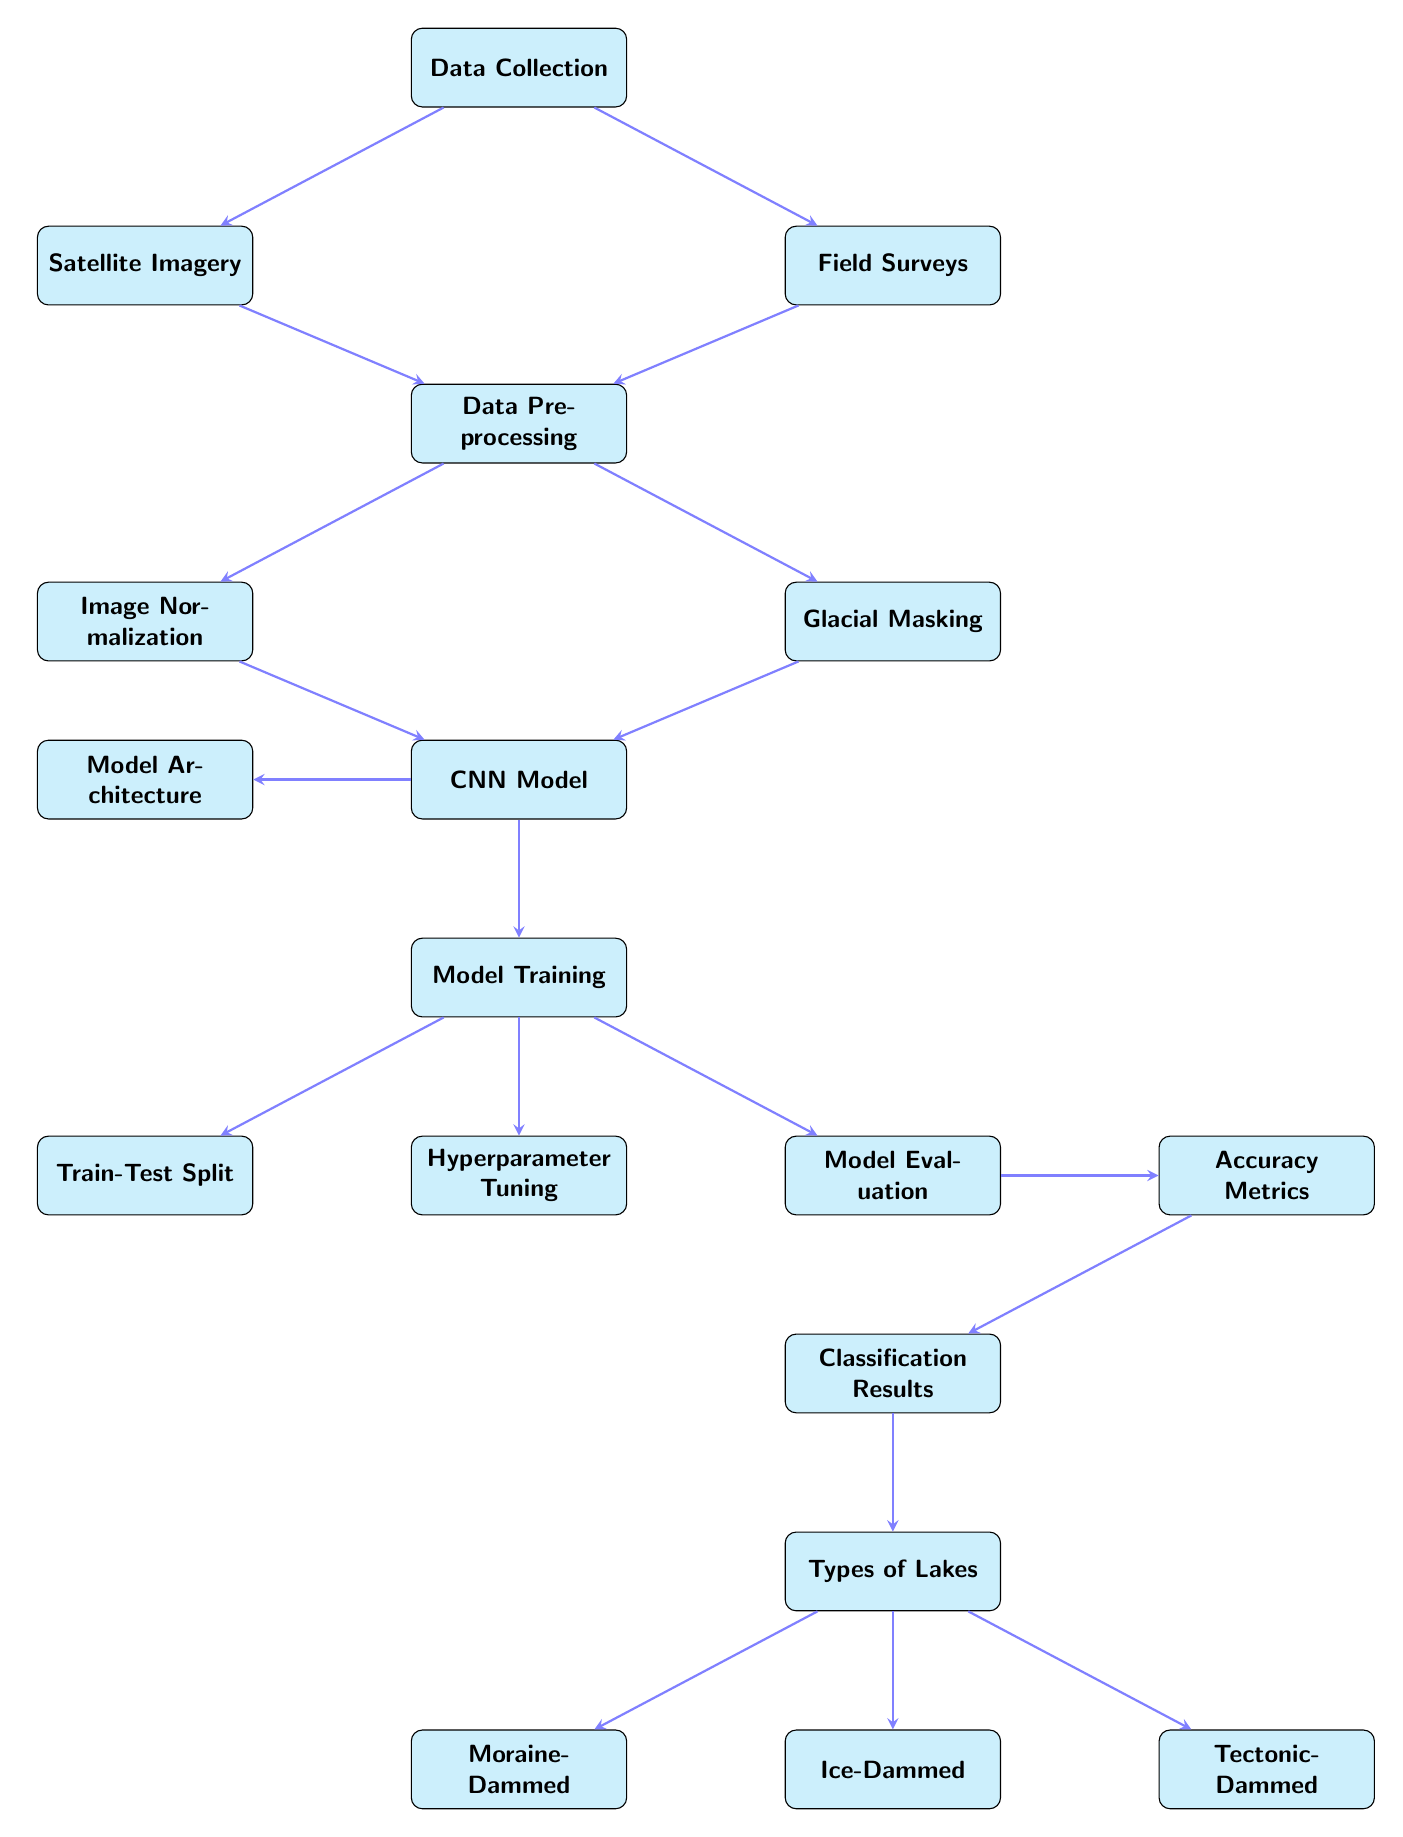What are the two main sources of data collection? The diagram indicates two primary sources of data collection: they're listed on the left side as "Satellite Imagery" and "Field Surveys". Both nodes are directly connected to the "Data Collection" node, showing their role as inputs for the process.
Answer: Satellite Imagery, Field Surveys How many types of lakes are classified in the results? At the bottom of the diagram, under the "Classification Results" node, there are three distinct nodes listed for types of lakes: "Moraine-Dammed", "Ice-Dammed", and "Tectonic-Dammed". Counting these nodes confirms the number of classifications.
Answer: Three What process comes after model training? Following the "Model Training" node, there are three subsequent processes which are indicated by arrows. The only node directly connected after model training is "Model Evaluation". This indicates the order of operations in the workflow.
Answer: Model Evaluation What is the purpose of the data preprocessing stage? The "Data Preprocessing" node occurs after the data has been collected from both sources, preparing it for analysis. This stage involves preparing the raw data (from both "Satellite Imagery" and "Field Surveys") before it is fed into the CNN model.
Answer: Prepare data for analysis Which node directly leads to the "CNN Model"? Two processes lead directly to the "CNN Model" node, specifically "Image Normalization" and "Glacial Masking". Both these steps are essential preprocesses contributing data to the CNN model's input.
Answer: Image Normalization, Glacial Masking During which phase is the accuracy of the model assessed? The stage where the model's accuracy is assessed is after "Model Evaluation". This node directly connects to "Accuracy Metrics", indicating this is when metrics are evaluated.
Answer: Model Evaluation Which process is fundamental for determining the efficiency of the model? The "Hyperparameter Tuning" node that branches from "Model Training" is crucial for improving the model's efficiency, as it optimizes the model's performance parameters. This directly affects how well the CNN model can classify glacial lakes.
Answer: Hyperparameter Tuning What is the significance of the "Train-Test Split" node? The "Train-Test Split" is a critical step after "Model Training" that prepares the data by dividing it into training and testing sets, ensuring the model's performance can be accurately evaluated using unseen data.
Answer: Prepare training and test data 